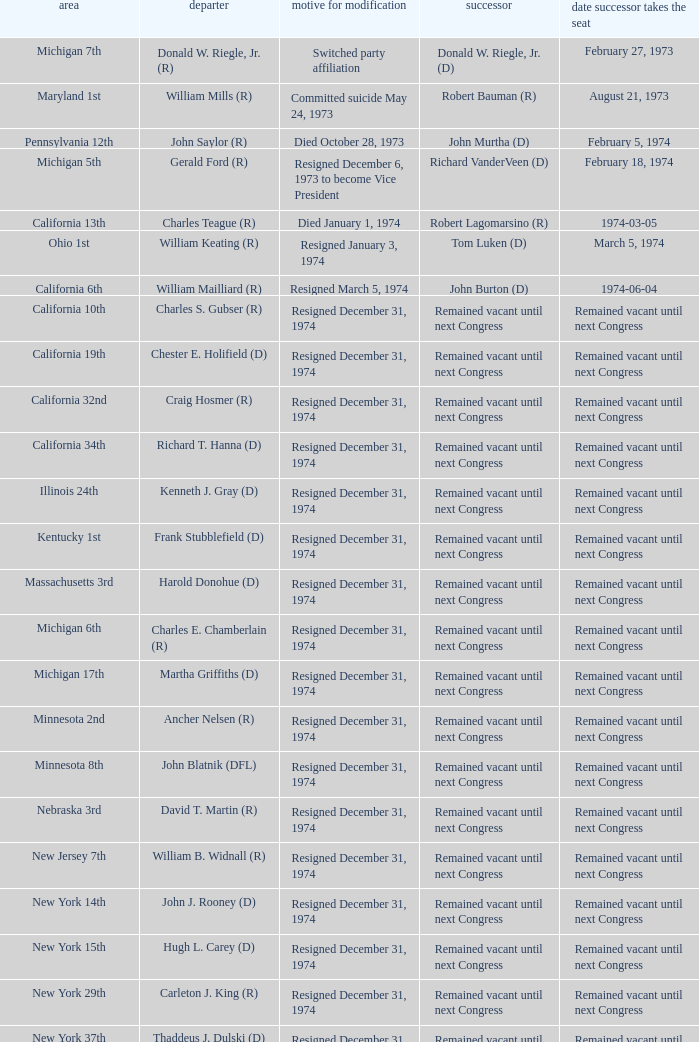When was the date successor seated when the vacator was charles e. chamberlain (r)? Remained vacant until next Congress. 